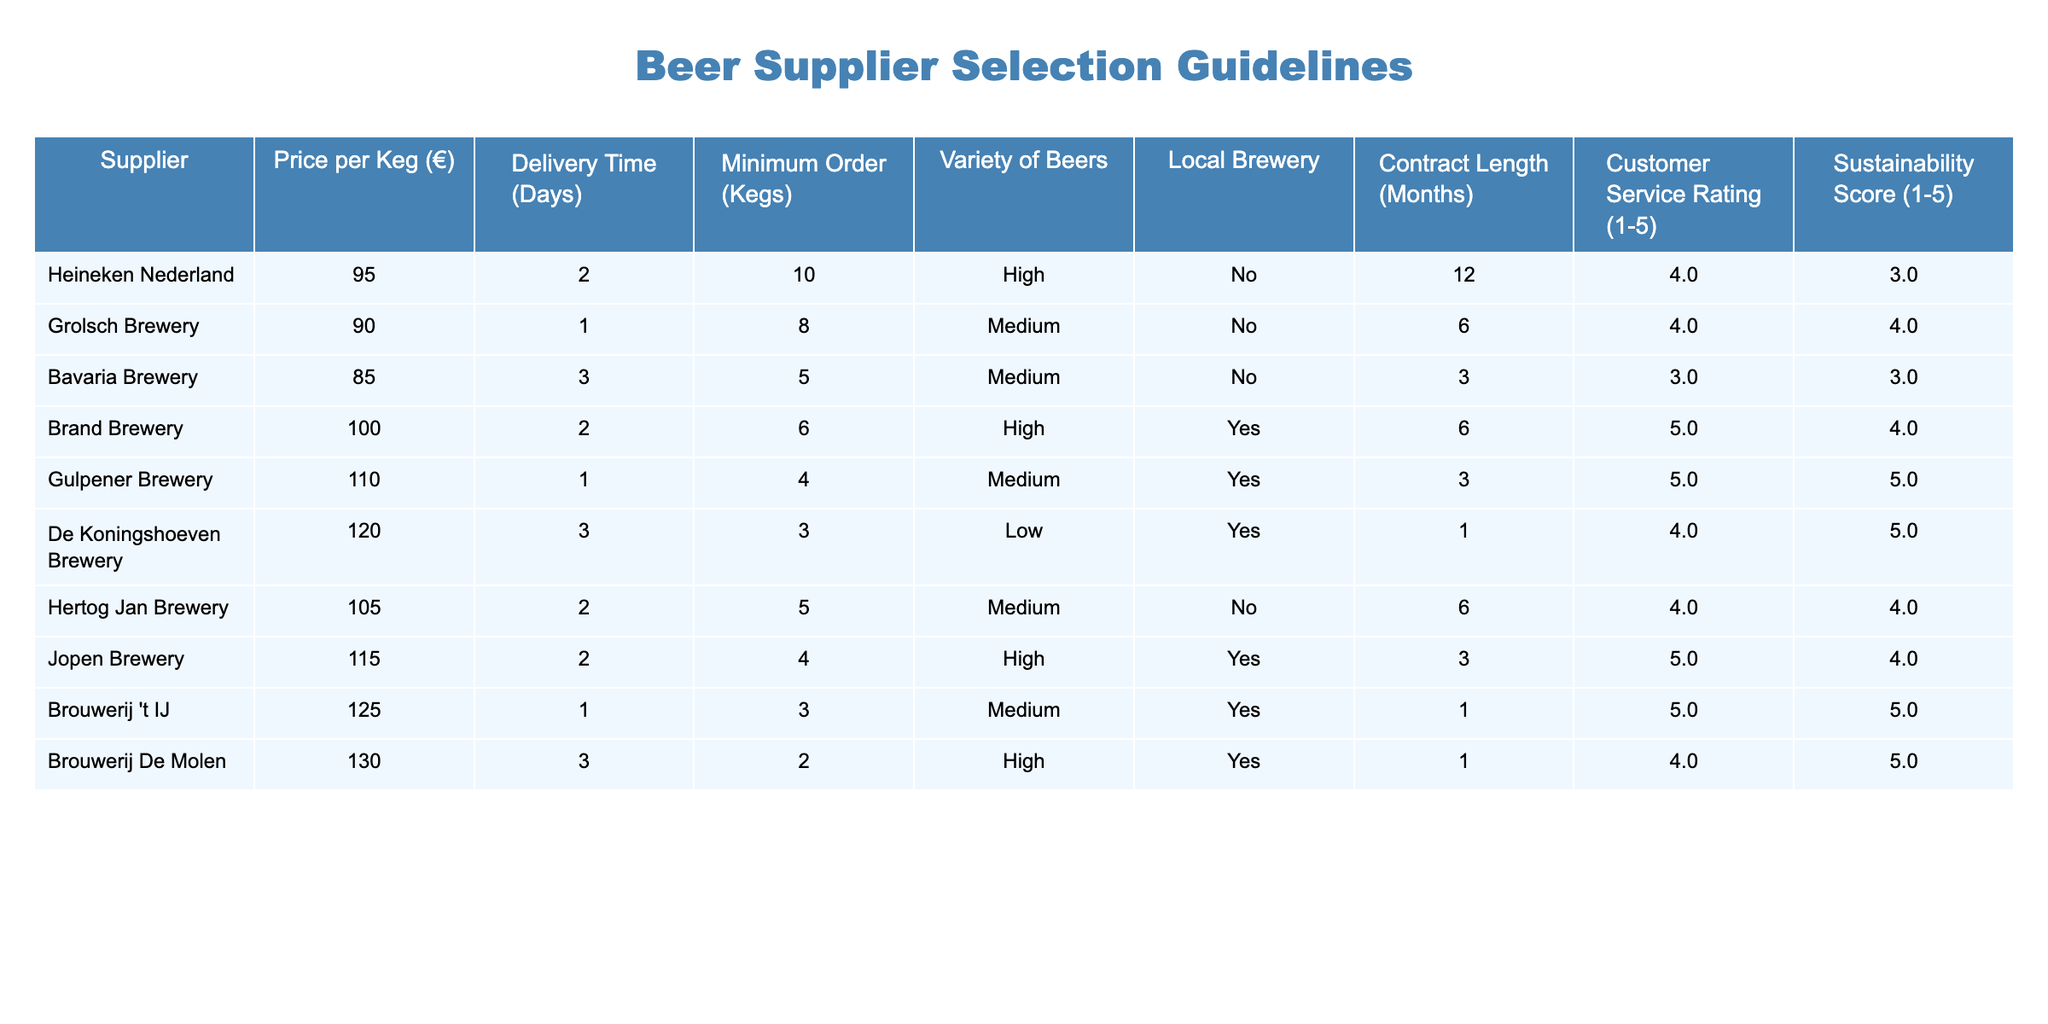What is the price per keg for Grolsch Brewery? The price per keg for Grolsch Brewery is listed directly in the table under the "Price per Keg (€)" column. It states €90.
Answer: 90 Which supplier has the highest customer service rating? To find this, we look for the maximum value in the "Customer Service Rating (1-5)" column. Brand Brewery has a rating of 5, which is the highest.
Answer: Brand Brewery How many breweries offer high variety of beers? We can count the entries labeled "High" in the "Variety of Beers" column. Heineken, Brand, and Jopen are the suppliers with high variety, totaling three.
Answer: 3 Is Gulpener Brewery a local brewery? The table indicates whether each brewery is local or not in the "Local Brewery" column. For Gulpener Brewery, it states "Yes," meaning it is indeed a local brewery.
Answer: Yes What is the average delivery time of all suppliers? To compute the average delivery time, sum the delivery times (2 + 1 + 3 + 2 + 1 + 3 + 2 + 2 + 1 + 3) to get a total of 20 days. Since there are 10 suppliers, the average is 20/10 = 2 days.
Answer: 2 Which supplier has the longest contract length and what is it? We scan the "Contract Length (Months)" column to find the maximum value. De Koningshoeven Brewery has a contract length of 1 month, which is the shortest. However, Brand and Grolsch both have a length of 6 months, which is the longest.
Answer: Brand Brewery and Grolsch Brewery (6 months) How many suppliers have a sustainability score above 4? We look at the "Sustainability Score (1-5)" column and count the values greater than 4. Gulpener, Brouwerij 't IJ, Brouwerij De Molen show scores of 5, making 3 suppliers in total.
Answer: 3 Is there at least one supplier that offers a delivery time of one day? Checking the "Delivery Time (Days)" column, both Grolsch Brewery and Gulpener Brewery have a delivery time of 1 day. Thus, the statement is true.
Answer: Yes What is the sum of the minimum orders for all suppliers that are also local breweries? The applicable rows are for Brand Brewery (6), Gulpener Brewery (4), Brouwerij 't IJ (3), and Brouwerij De Molen (2). Summing these minimum orders gives 6 + 4 + 3 + 2 = 15 kegs.
Answer: 15 